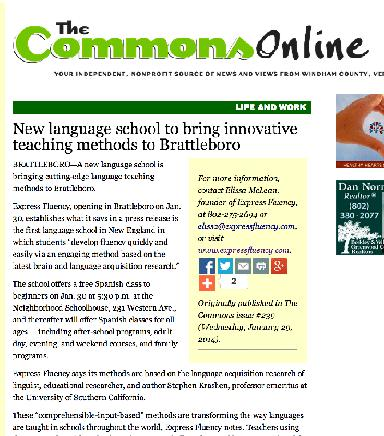What is the teaching method mentioned in the image based on? The teaching methods adopted by the school are inspired by the renowned education researcher Stephen Krashen. His theories emphasize natural language acquisition focusing on meaningful communication rather than rote memorization, aiming to create a more engaging and effective learning atmosphere. 